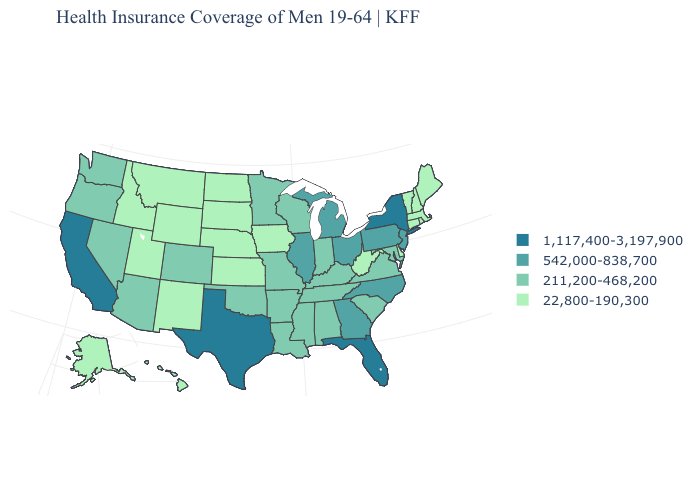Does the first symbol in the legend represent the smallest category?
Be succinct. No. What is the value of Oklahoma?
Answer briefly. 211,200-468,200. Which states hav the highest value in the Northeast?
Short answer required. New York. Which states have the highest value in the USA?
Keep it brief. California, Florida, New York, Texas. Which states have the highest value in the USA?
Write a very short answer. California, Florida, New York, Texas. What is the lowest value in states that border Oregon?
Short answer required. 22,800-190,300. Which states have the lowest value in the MidWest?
Write a very short answer. Iowa, Kansas, Nebraska, North Dakota, South Dakota. Name the states that have a value in the range 22,800-190,300?
Answer briefly. Alaska, Connecticut, Delaware, Hawaii, Idaho, Iowa, Kansas, Maine, Massachusetts, Montana, Nebraska, New Hampshire, New Mexico, North Dakota, Rhode Island, South Dakota, Utah, Vermont, West Virginia, Wyoming. Which states hav the highest value in the Northeast?
Be succinct. New York. How many symbols are there in the legend?
Concise answer only. 4. Is the legend a continuous bar?
Keep it brief. No. Which states have the lowest value in the USA?
Write a very short answer. Alaska, Connecticut, Delaware, Hawaii, Idaho, Iowa, Kansas, Maine, Massachusetts, Montana, Nebraska, New Hampshire, New Mexico, North Dakota, Rhode Island, South Dakota, Utah, Vermont, West Virginia, Wyoming. Which states have the lowest value in the West?
Write a very short answer. Alaska, Hawaii, Idaho, Montana, New Mexico, Utah, Wyoming. Name the states that have a value in the range 211,200-468,200?
Write a very short answer. Alabama, Arizona, Arkansas, Colorado, Indiana, Kentucky, Louisiana, Maryland, Minnesota, Mississippi, Missouri, Nevada, Oklahoma, Oregon, South Carolina, Tennessee, Virginia, Washington, Wisconsin. 